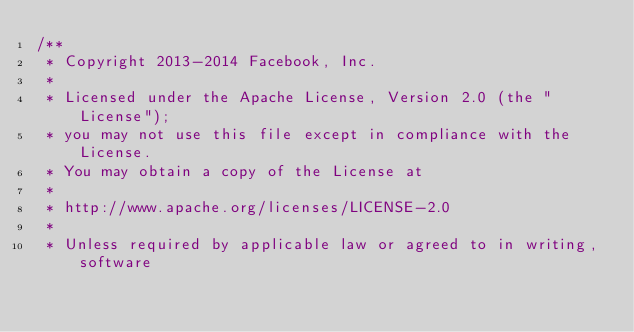Convert code to text. <code><loc_0><loc_0><loc_500><loc_500><_JavaScript_>/**
 * Copyright 2013-2014 Facebook, Inc.
 *
 * Licensed under the Apache License, Version 2.0 (the "License");
 * you may not use this file except in compliance with the License.
 * You may obtain a copy of the License at
 *
 * http://www.apache.org/licenses/LICENSE-2.0
 *
 * Unless required by applicable law or agreed to in writing, software</code> 